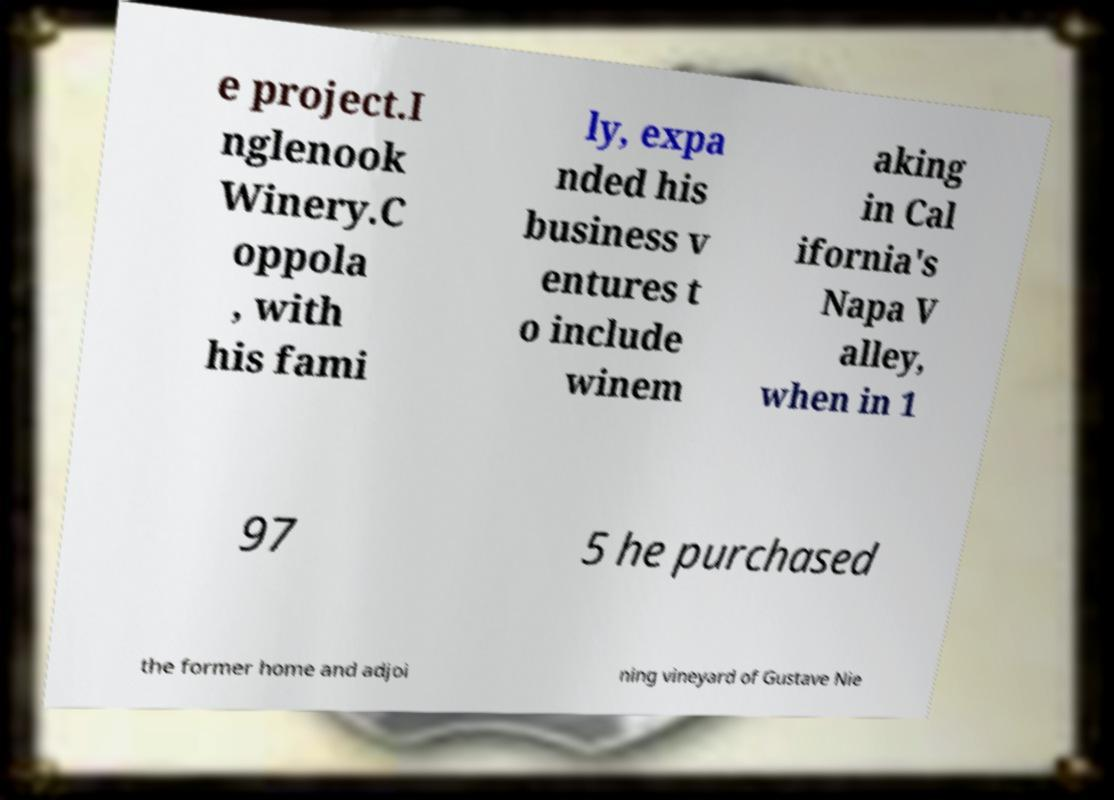Can you read and provide the text displayed in the image?This photo seems to have some interesting text. Can you extract and type it out for me? e project.I nglenook Winery.C oppola , with his fami ly, expa nded his business v entures t o include winem aking in Cal ifornia's Napa V alley, when in 1 97 5 he purchased the former home and adjoi ning vineyard of Gustave Nie 